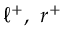Convert formula to latex. <formula><loc_0><loc_0><loc_500><loc_500>\ell ^ { + } , \ r ^ { + }</formula> 